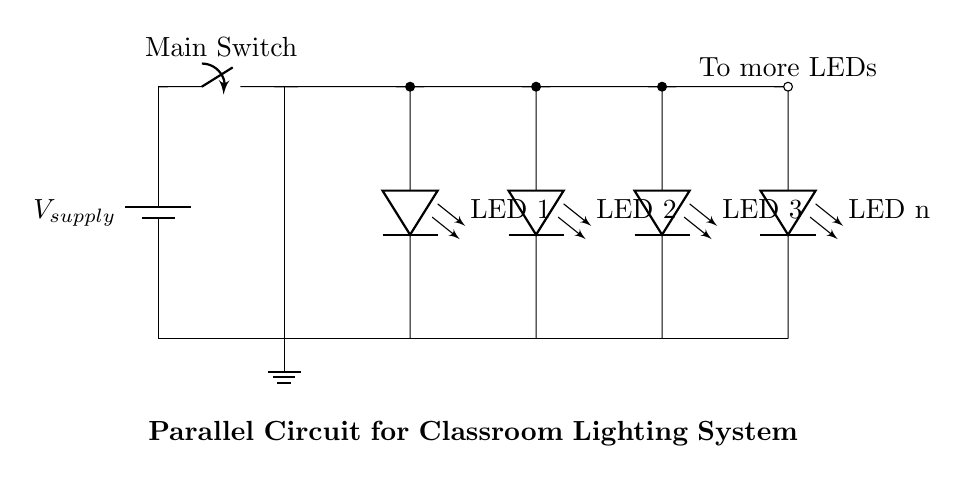What type of circuit design is illustrated? The circuit is a parallel design, evidenced by the multiple branches connecting the LEDs directly to the voltage supply, allowing each LED to operate independently.
Answer: Parallel How many LED bulbs are in the circuit? The circuit shows three specifically labeled LED bulbs, and one additional LED labeled as 'LED n', indicating there may be more. Thus, there are at least four LED bulbs visible.
Answer: Four What is the role of the main switch? The main switch controls the flow of current from the power supply, allowing or preventing the current from reaching the parallel branches and the LED bulbs.
Answer: Control power What happens to other LEDs if one LED fails? Since the LEDs are in parallel, if one LED fails (open circuit), the other LEDs will still function normally because they have separate paths to the power supply.
Answer: Others stay lit What is the connection type of the LEDs in this circuit? The LEDs are connected in parallel because they each have separate connections to the power supply, demonstrating that multiple paths are available for the current.
Answer: Parallel connection What voltage is likely applied across each LED? Each LED in a parallel circuit receives the same voltage as the supply, indicated by the direct connection to the voltage source, which is common to all branches.
Answer: Supply voltage If the total current is measured, how does it compare to the current through each LED? The total current in a parallel circuit is the sum of currents flowing through each LED, meaning the total current will be greater than the current through any individual LED.
Answer: Greater sum 